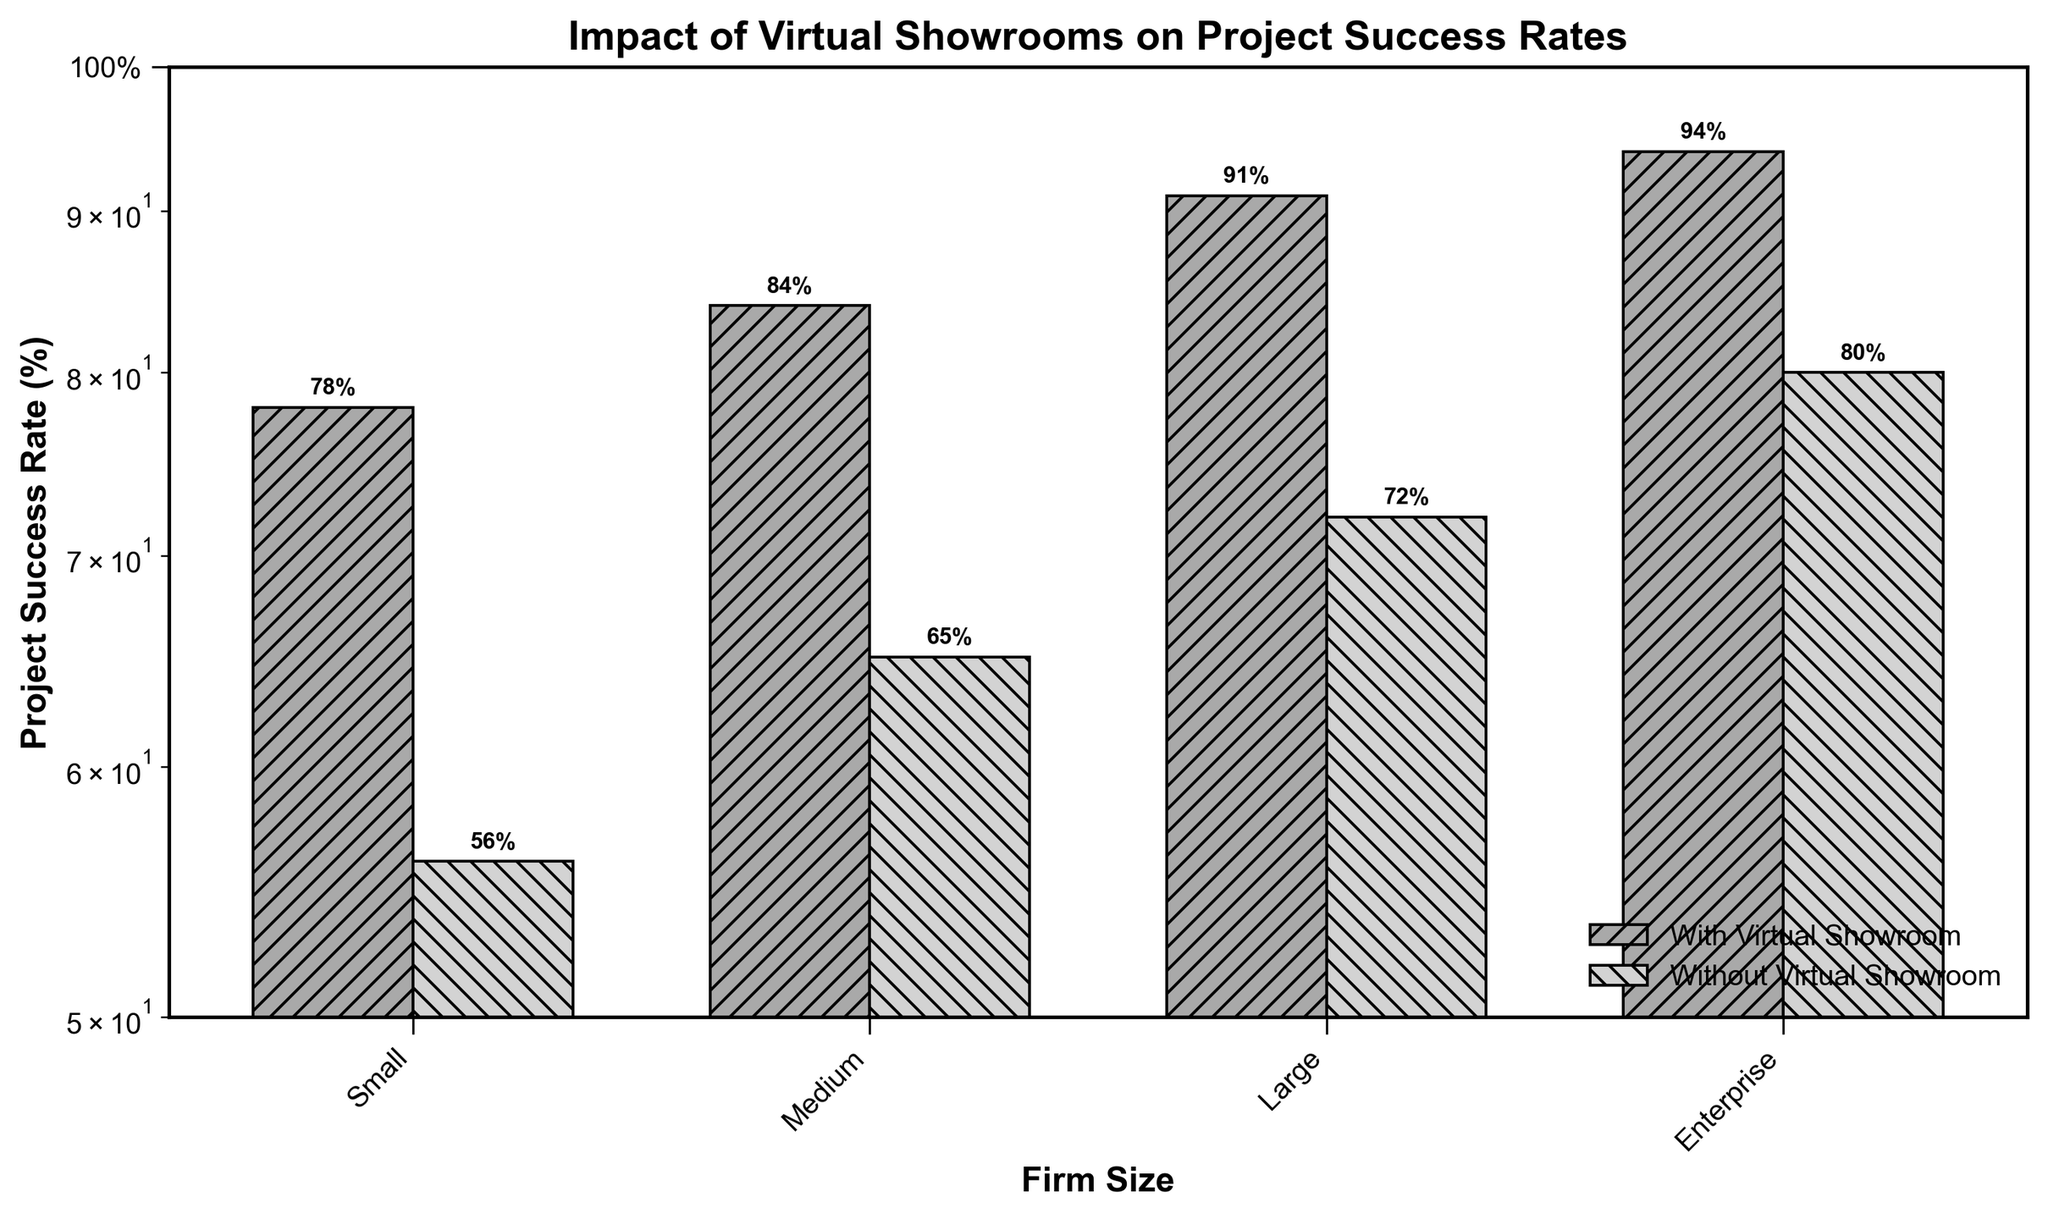What's the title of the figure? Looking at the top of the figure, the title is clearly mentioned.
Answer: Impact of Virtual Showrooms on Project Success Rates What's the firm size with the highest project success rate when using virtual showrooms? We need to identify the bar corresponding to the highest value among the 'With Virtual Showroom' bars. The 'Enterprise' firm size has the highest bar.
Answer: Enterprise How much higher is the project success rate for small firms using virtual showrooms compared to those not using them? Subtract the success rate for small firms not using virtual showrooms (56%) from those using them (78%). 78% - 56% = 22%.
Answer: 22% What's the difference in project success rate between medium and large firms without virtual showrooms? Subtract the success rate of medium firms without virtual showrooms (65%) from large firms without virtual showrooms (72%). 72% - 65% = 7%.
Answer: 7% Are project success rates generally higher with the use of virtual showrooms? Compare the height of the bars for 'With Virtual Showroom' with their corresponding 'Without Virtual Showroom' bars. All 'With Virtual Showroom' bars are higher.
Answer: Yes Which firm size has the smallest difference in project success rates between using and not using virtual showrooms? Calculate the differences for each firm size: Small (78-56=22), Medium (84-65=19), Large (91-72=19), and Enterprise (94-80=14). The smallest difference is for Enterprise.
Answer: Enterprise What is the average project success rate for firms not using virtual showrooms? Add the success rates of all firm sizes not using virtual showrooms (56, 65, 72, 80) and divide by 4. (56 + 65 + 72 + 80) / 4 = 273 / 4 = 68.25%.
Answer: 68.25% By what percentage does the project success rate increase for large firms when using virtual showrooms? Subtract the success rate without virtual showrooms (72%) from with virtual showrooms (91%) and divide by 72%. 91 - 72 = 19. Then, (19 / 72) x 100 ≈ 26.39%.
Answer: 26.39% What do the hatch patterns (/// and \\\) represent in the bars? In the legend at the bottom right, the patterns are explained. /// represents 'With Virtual Showroom' and \\\ represents 'Without Virtual Showroom'.
Answer: Differentiate between 'With Virtual Showroom' and 'Without Virtual Showroom' Why is the y-axis scaled logarithmically? The y-axis is scaled logarithmically to better display and differentiate the lower success rates while still accommodating higher rates effectively.
Answer: To better differentiate success rates 